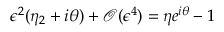<formula> <loc_0><loc_0><loc_500><loc_500>\epsilon ^ { 2 } ( \eta _ { 2 } + i \theta ) + \mathcal { O } ( \epsilon ^ { 4 } ) = \eta e ^ { i \theta } - 1</formula> 